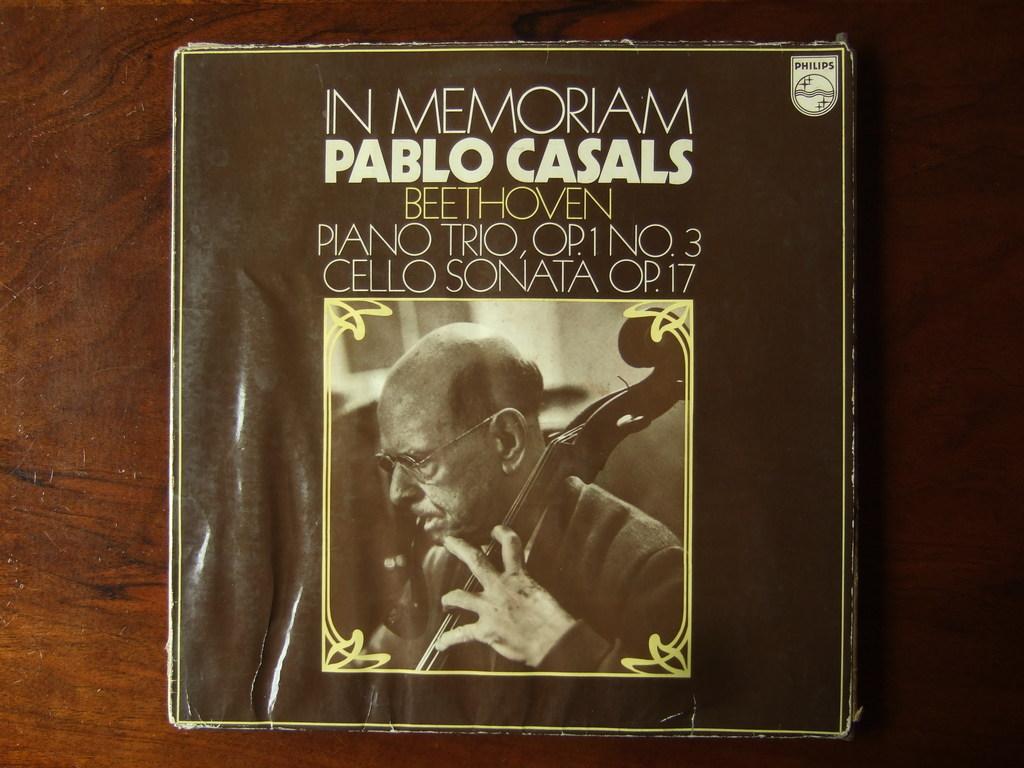Who's sonata is this?
Provide a succinct answer. Beethoven. What is the title of this book?
Give a very brief answer. In memoriam. 